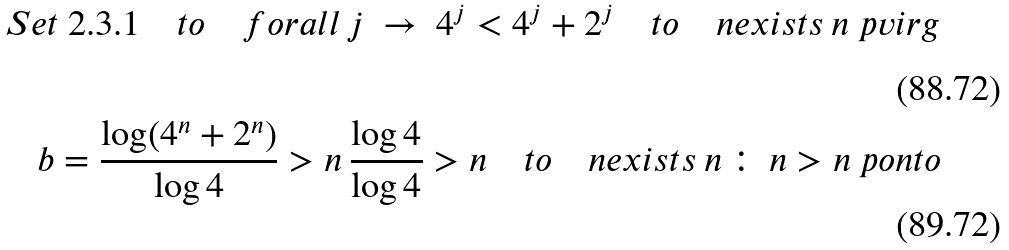<formula> <loc_0><loc_0><loc_500><loc_500>S e t \ 2 . 3 . 1 \quad t o \quad f o r a l l \, j \ \to \ 4 ^ { j } < 4 ^ { j } + 2 ^ { j } \quad t o \quad n e x i s t s \, n \ p v i r g \\ b = \frac { \log ( 4 ^ { n } + 2 ^ { n } ) } { \log 4 } > n \, \frac { \log 4 } { \log 4 } > n \quad t o \quad n e x i s t s \, n \, \colon \, n > n \ p o n t o</formula> 